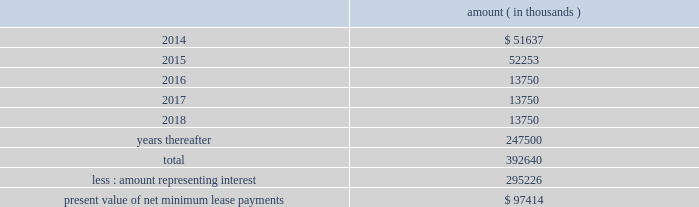Entergy corporation and subsidiaries notes to financial statements this difference as a regulatory asset or liability on an ongoing basis , resulting in a zero net balance for the regulatory asset at the end of the lease term .
The amount was a net regulatory liability of $ 61.6 million and $ 27.8 million as of december 31 , 2013 and 2012 , respectively .
As of december 31 , 2013 , system energy had future minimum lease payments ( reflecting an implicit rate of 5.13% ( 5.13 % ) ) , which are recorded as long-term debt , as follows : amount ( in thousands ) .

What is the percent change in future minimum lease payments from 2015 to 2016? 
Computations: ((52253 - 13750) / 13750)
Answer: 2.80022. 